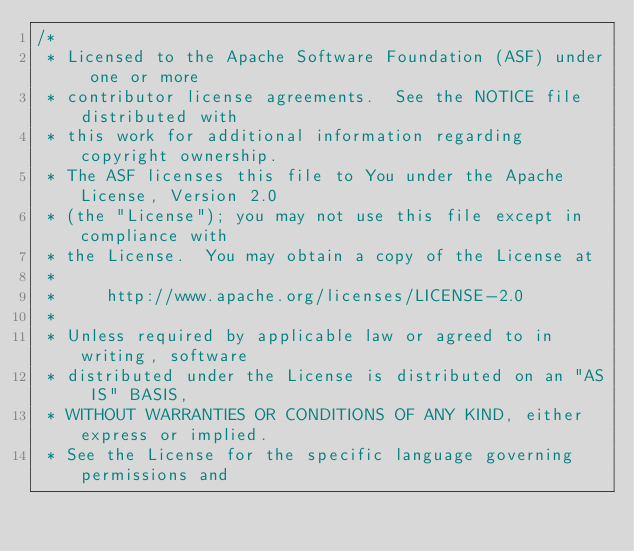Convert code to text. <code><loc_0><loc_0><loc_500><loc_500><_C++_>/*
 * Licensed to the Apache Software Foundation (ASF) under one or more
 * contributor license agreements.  See the NOTICE file distributed with
 * this work for additional information regarding copyright ownership.
 * The ASF licenses this file to You under the Apache License, Version 2.0
 * (the "License"); you may not use this file except in compliance with
 * the License.  You may obtain a copy of the License at
 *
 *     http://www.apache.org/licenses/LICENSE-2.0
 *
 * Unless required by applicable law or agreed to in writing, software
 * distributed under the License is distributed on an "AS IS" BASIS,
 * WITHOUT WARRANTIES OR CONDITIONS OF ANY KIND, either express or implied.
 * See the License for the specific language governing permissions and</code> 